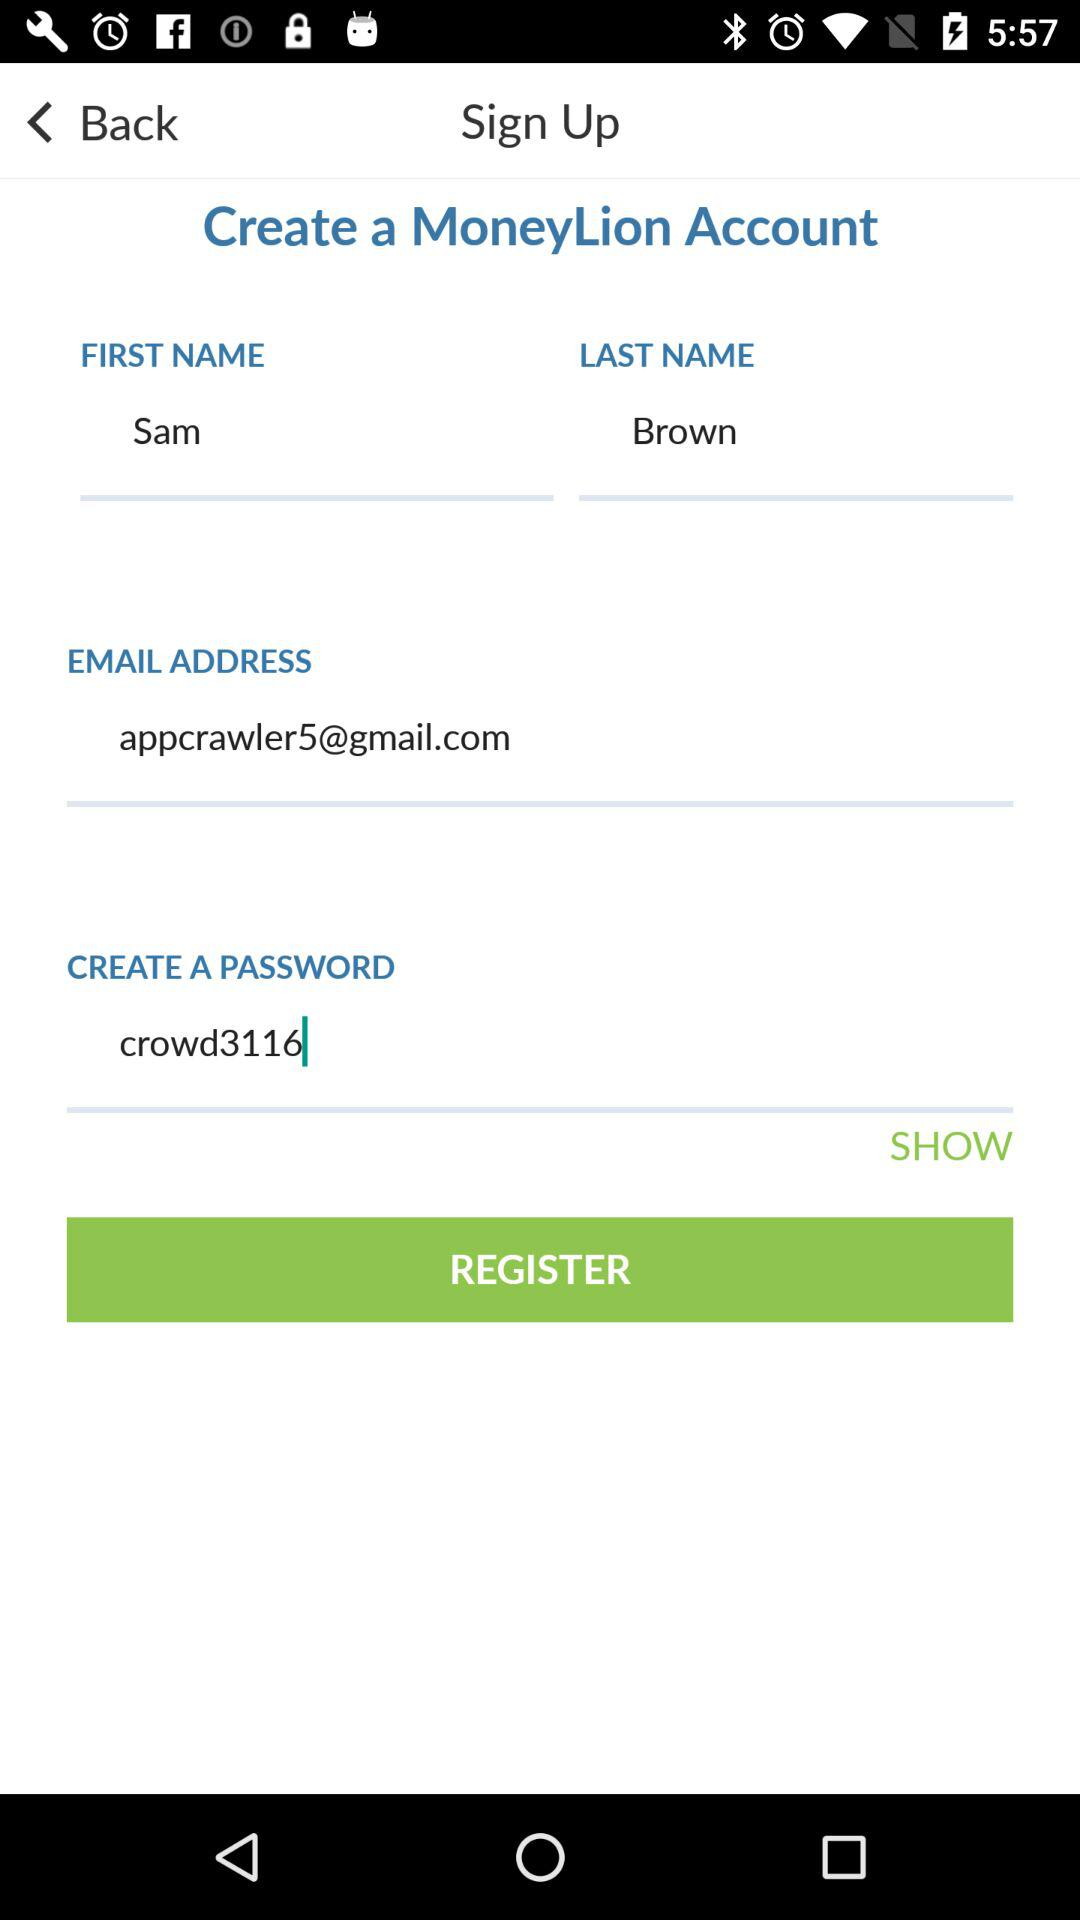What is the last name of the user? The last name is Brown. 